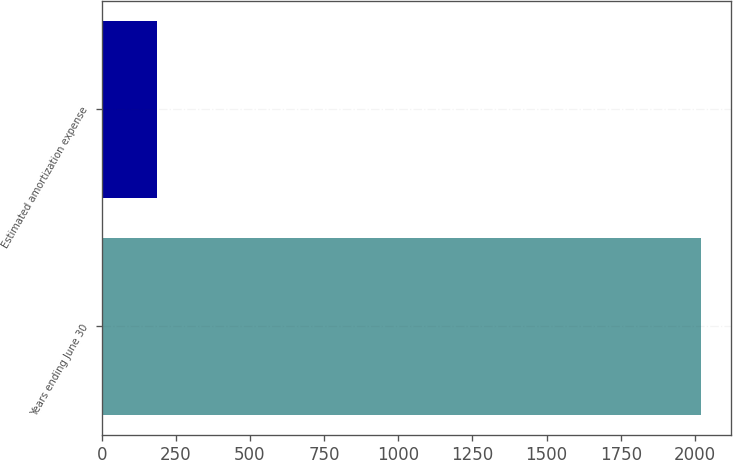Convert chart. <chart><loc_0><loc_0><loc_500><loc_500><bar_chart><fcel>Years ending June 30<fcel>Estimated amortization expense<nl><fcel>2022<fcel>185<nl></chart> 